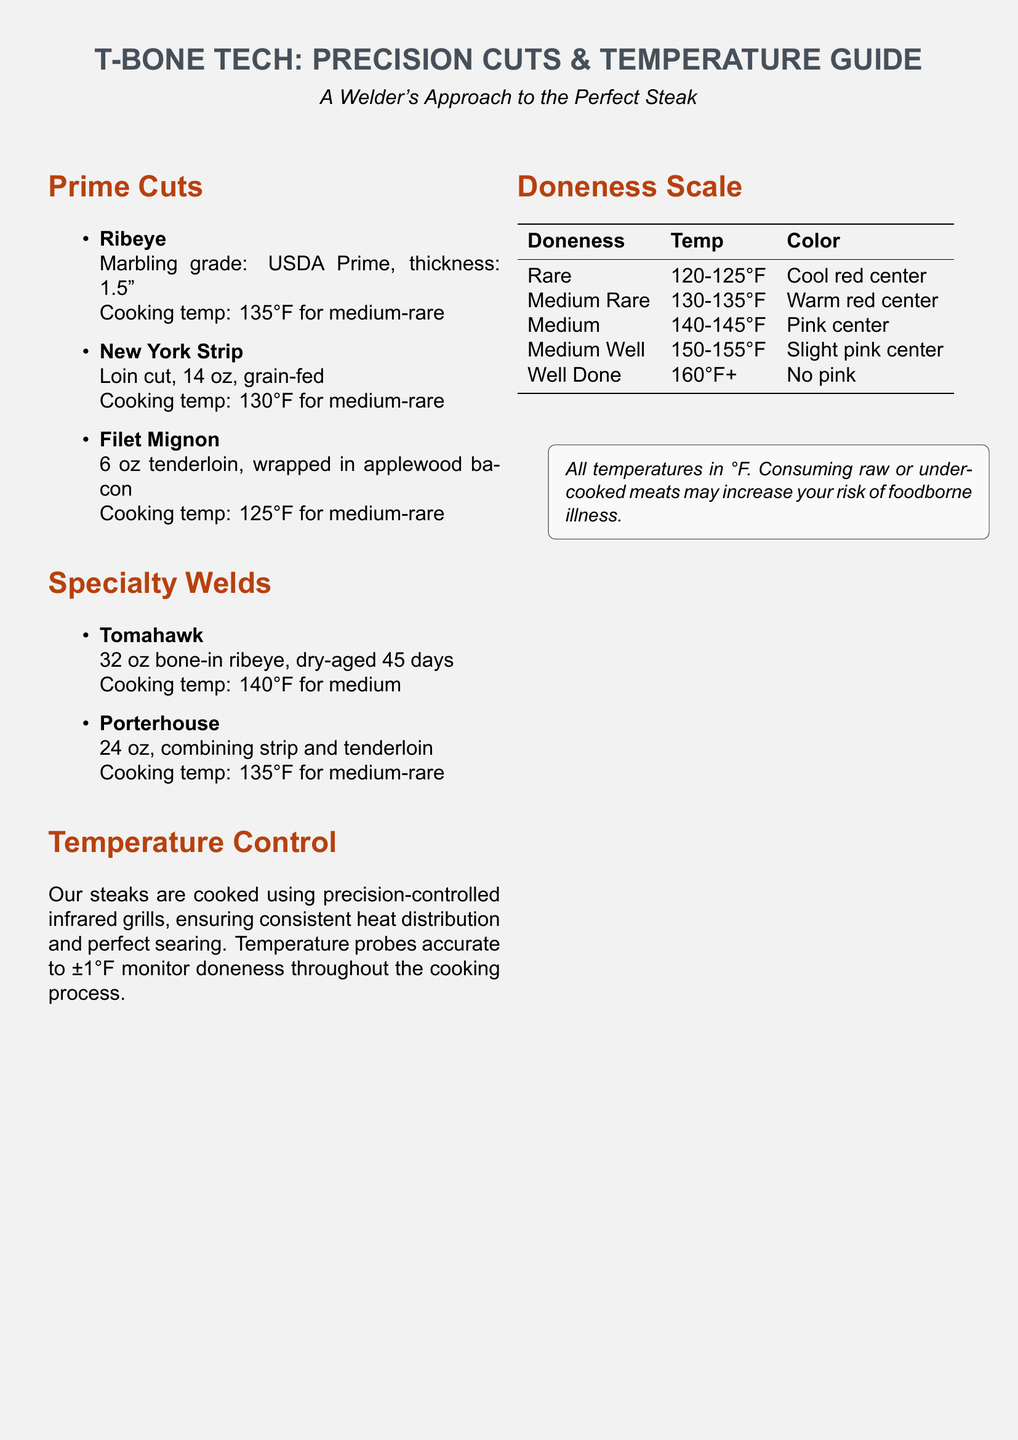What is the thickness of the Ribeye cut? The thickness of the Ribeye cut is stated as 1.5 inches in the document.
Answer: 1.5" What is the cooking temperature for Filet Mignon? The cooking temperature for Filet Mignon is provided in the menu as 125°F for medium-rare.
Answer: 125°F How many ounces is the New York Strip? The New York Strip is listed as 14 ounces in the document.
Answer: 14 oz What type of cooking appliances are used? The document mentions that precision-controlled infrared grills are used for cooking.
Answer: Infrared grills What doneness stage has a warm red center? The doneness stage with a warm red center is defined as Medium Rare in the menu.
Answer: Medium Rare What is the weight of the Tomahawk steak? The weight of the Tomahawk steak is specified as 32 ounces in the document.
Answer: 32 oz At what temperature is a Medium steak cooked? The cooking temperature for a Medium steak is stated to be 140°F in the document.
Answer: 140°F What color is associated with Well Done steaks? The color associated with Well Done steaks is described as having no pink in the document.
Answer: No pink How long is the Tomahawk dry-aged? The Tomahawk steak is dry-aged for 45 days as indicated in the document.
Answer: 45 days 